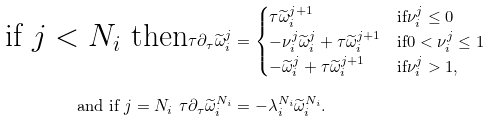Convert formula to latex. <formula><loc_0><loc_0><loc_500><loc_500>\text {if $j<N_{i}$ then} \tau \partial _ { \tau } \widetilde { \omega } _ { i } ^ { j } & = \begin{cases} \tau \widetilde { \omega } _ { i } ^ { j + 1 } & \text {if} \nu _ { i } ^ { j } \leq 0 \\ - \nu _ { i } ^ { j } \widetilde { \omega } _ { i } ^ { j } + \tau \widetilde { \omega } _ { i } ^ { j + 1 } & \text {if} 0 < \nu _ { i } ^ { j } \leq 1 \\ - \widetilde { \omega } _ { i } ^ { j } + \tau \widetilde { \omega } _ { i } ^ { j + 1 } & \text {if} \nu _ { i } ^ { j } > 1 , \end{cases} \\ \text {and if $j=N_{i}$ } \tau \partial _ { \tau } \widetilde { \omega } _ { i } ^ { N _ { i } } & = - \lambda _ { i } ^ { N _ { i } } \widetilde { \omega } _ { i } ^ { N _ { i } } .</formula> 